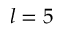<formula> <loc_0><loc_0><loc_500><loc_500>l = 5</formula> 